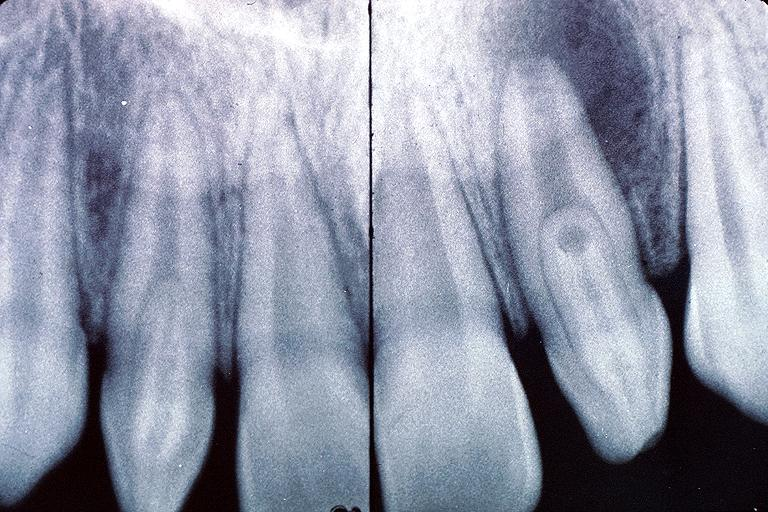what does this image show?
Answer the question using a single word or phrase. Dens invaginatus 